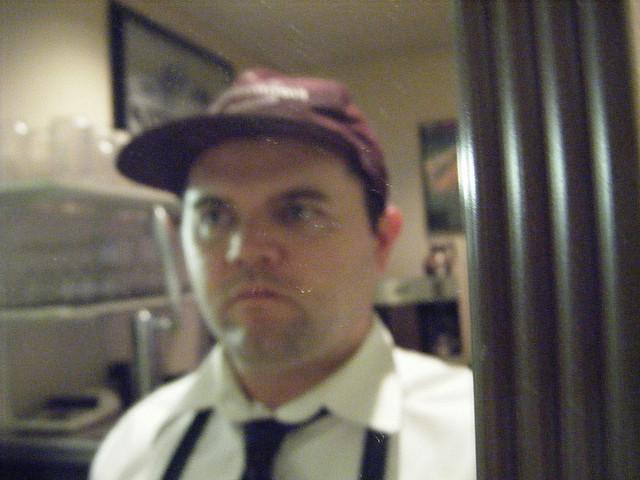Is the photo blurry?
Keep it brief. Yes. What color hat is he wearing?
Short answer required. Maroon. Is the man angry?
Short answer required. Yes. 